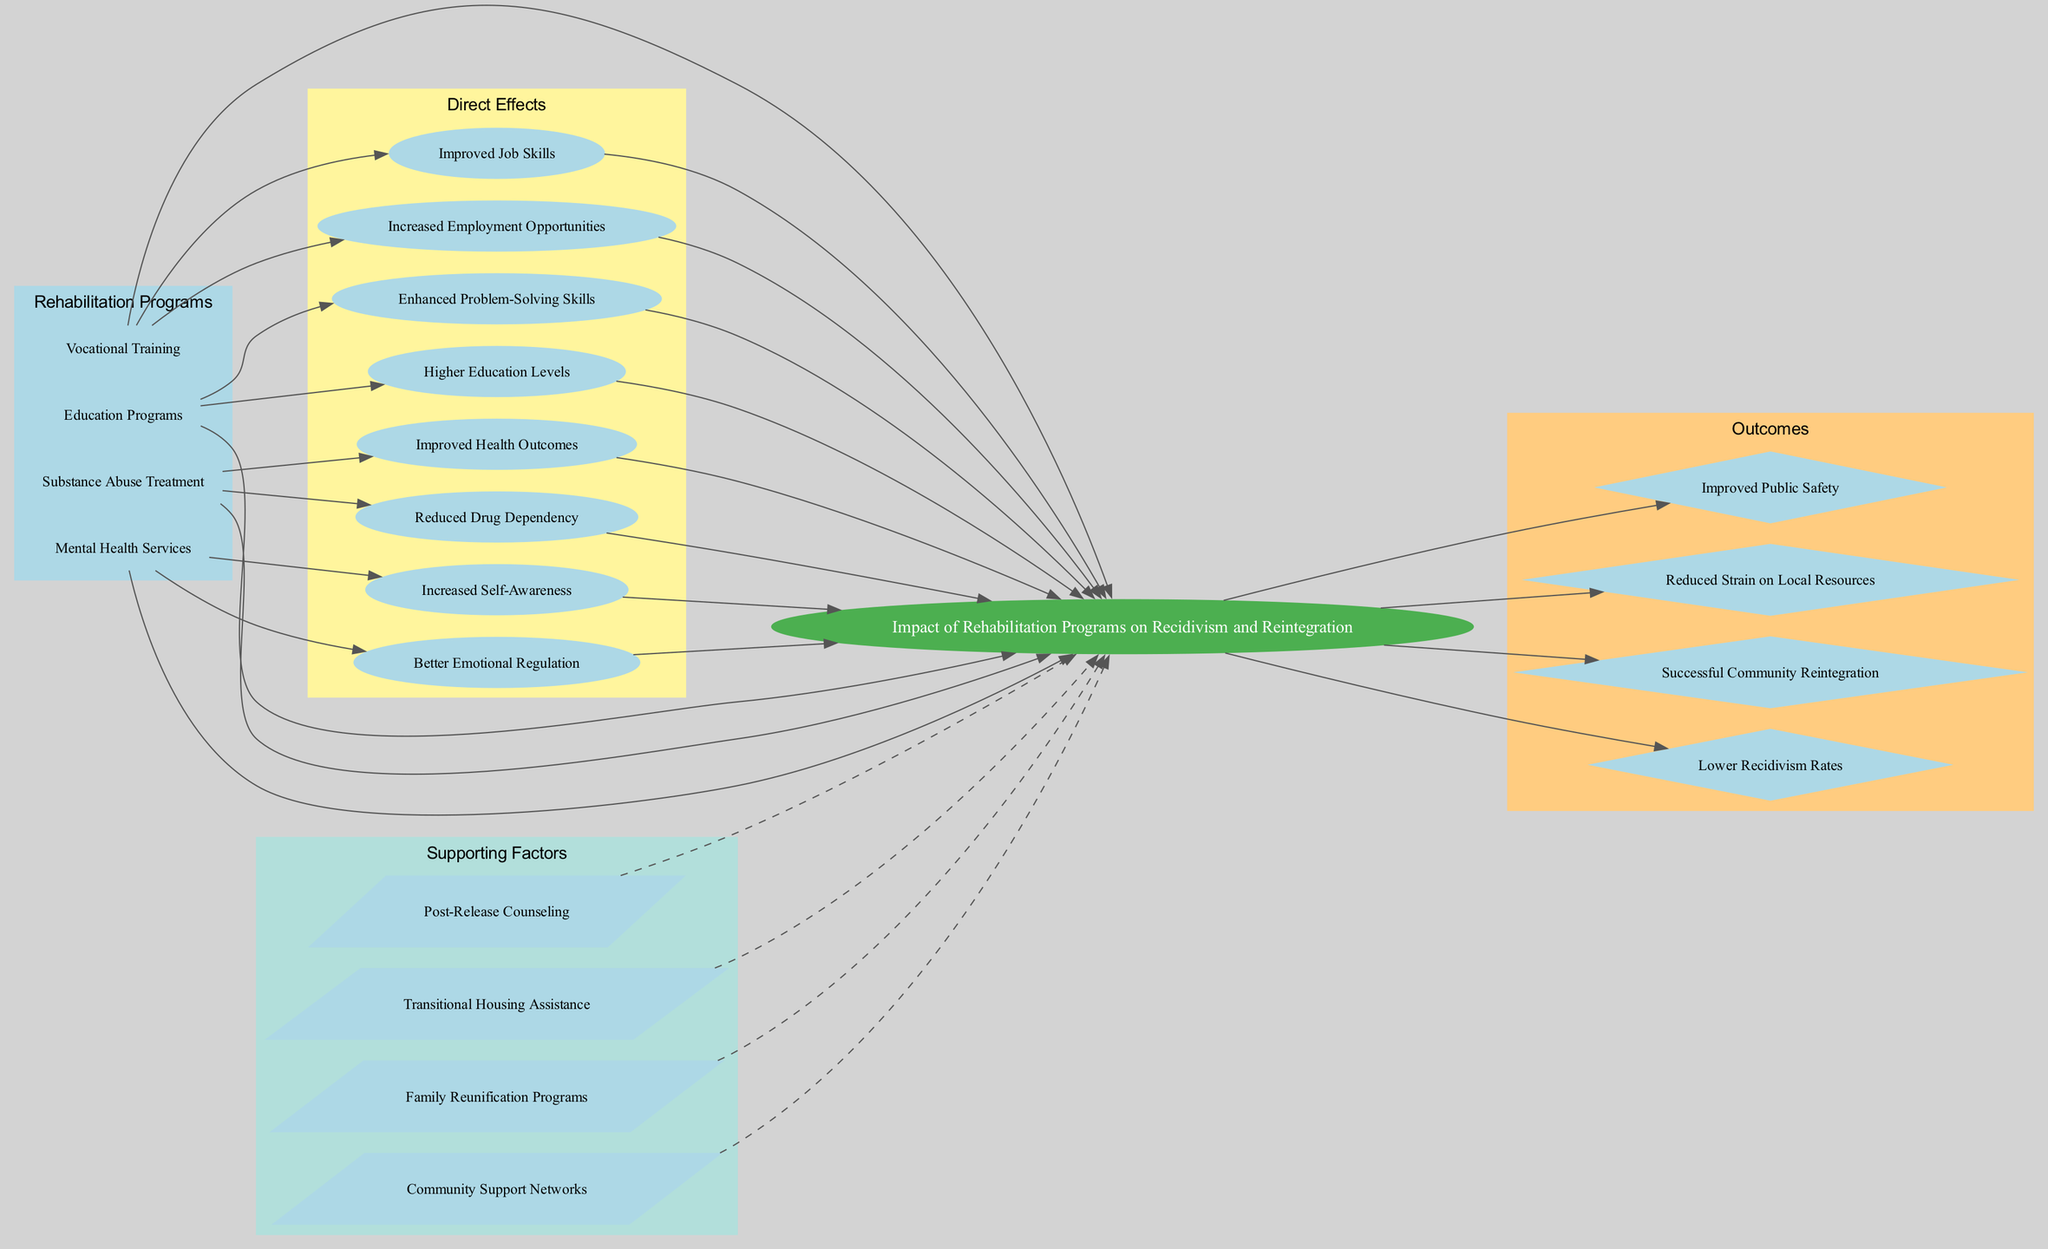What is the central theme of the diagram? The central node is labeled "Impact of Rehabilitation Programs on Recidivism and Reintegration," which indicates that this is the main focus of the diagram.
Answer: Impact of Rehabilitation Programs on Recidivism and Reintegration How many main causes are listed in the diagram? The diagram contains a section with main causes, specifically listing four programs: "Vocational Training," "Education Programs," "Substance Abuse Treatment," and "Mental Health Services." Hence, there are four main causes.
Answer: 4 Which program leads to "Reduced Drug Dependency"? By examining the effects associated with each rehabilitation program, "Substance Abuse Treatment" is connected directly to the effect "Reduced Drug Dependency."
Answer: Substance Abuse Treatment What is one effect of the "Mental Health Services"? The diagram shows that "Mental Health Services" has effects such as "Better Emotional Regulation" and "Increased Self-Awareness," indicating the benefits of this program.
Answer: Better Emotional Regulation Which outcome is directly linked to the central theme? The outcomes include "Lower Recidivism Rates," "Successful Community Reintegration," "Reduced Strain on Local Resources," and "Improved Public Safety," all of which are directly connected to the central theme in the diagram.
Answer: Lower Recidivism Rates What type of node is used to represent "Family Reunification Programs"? The supporting factors section contains several nodes, and "Family Reunification Programs" is represented in the diagram as a "parallelogram," which is the specific shape assigned to supporting factors.
Answer: Parallelogram Which supporting factor is dashed in its connection? The supporting factors are connected to the central theme using dashed edges, indicating their supportive role, among which "Community Support Networks" is one.
Answer: Community Support Networks What is a relationship between "Education Programs" and "Higher Education Levels"? "Education Programs" is a main cause leading to "Higher Education Levels," showing that there’s a direct edge connection from the cause to the effect in the diagram.
Answer: Education Programs leads to Higher Education Levels What is the color of the nodes representing main causes? The nodes for main causes such as "Vocational Training," "Education Programs," "Substance Abuse Treatment," and "Mental Health Services" are filled with light blue color, distinguishing them from other types of nodes in the diagram.
Answer: Light blue 